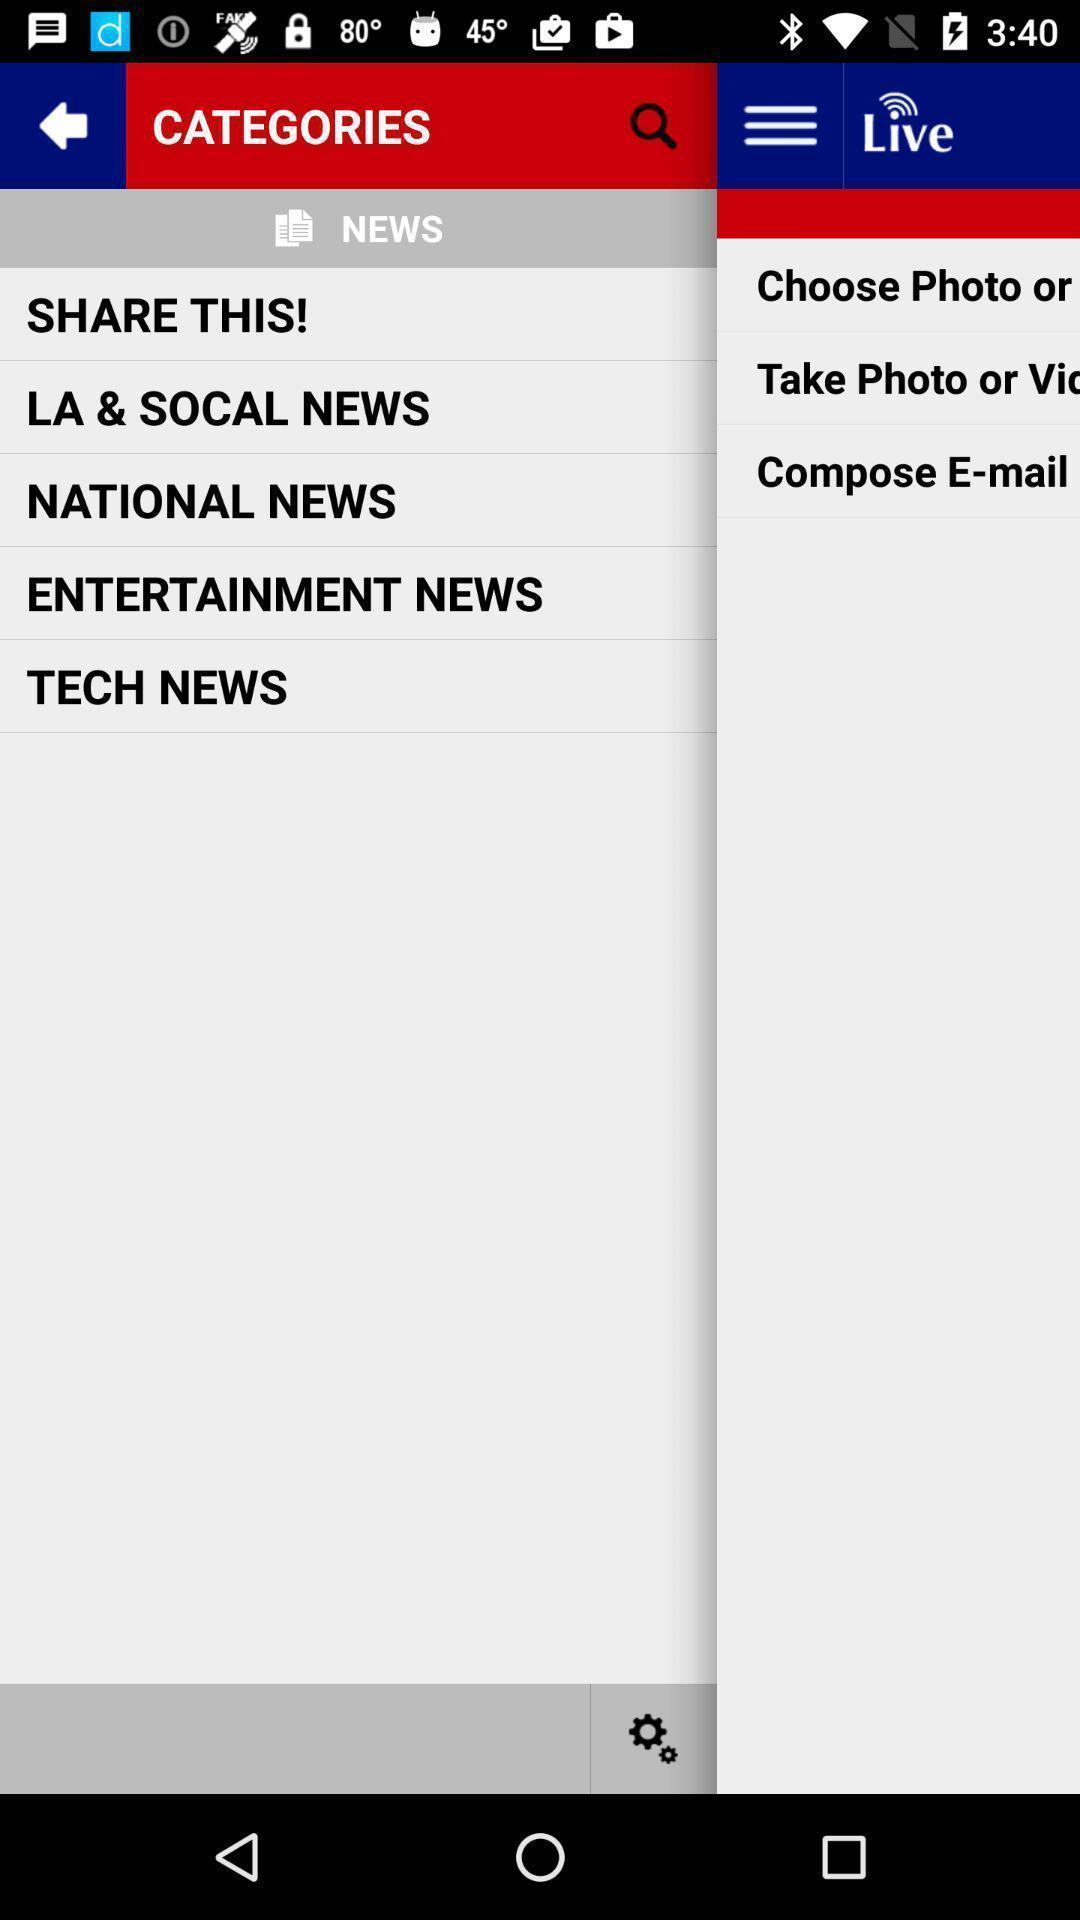Explain what's happening in this screen capture. Screen displaying multiple news options and a search icon. 